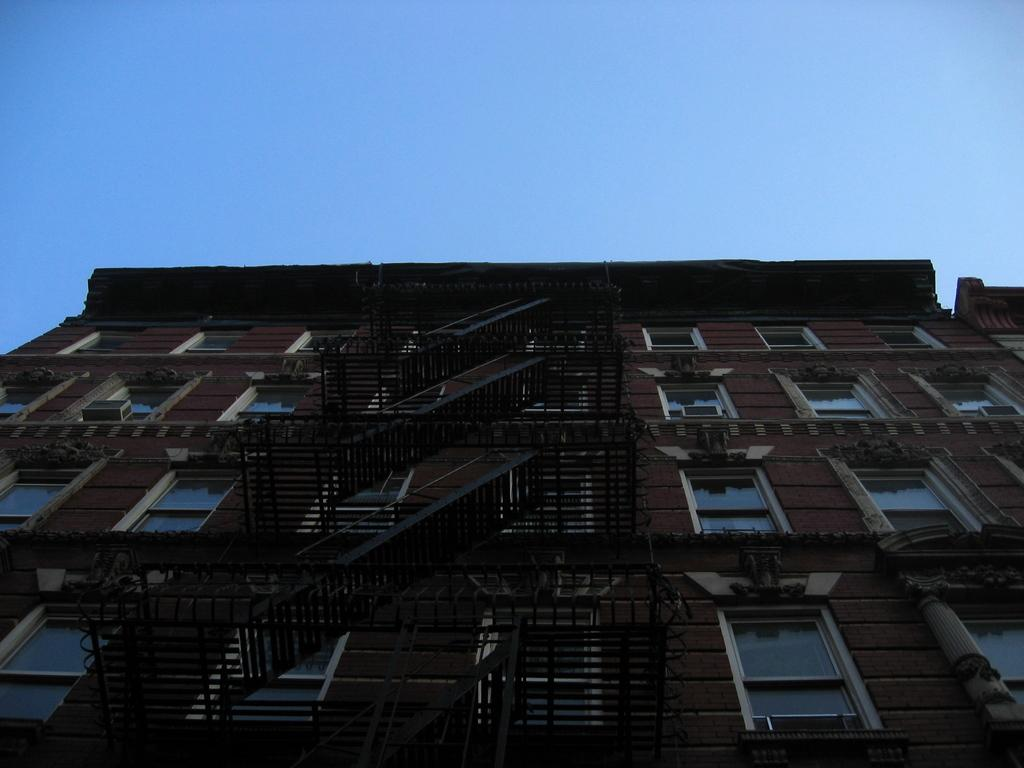What is visible at the top of the image? The sky is visible at the top of the image. What type of structure can be seen in the image? There is a building in the image. What architectural feature is present in the building? There are staircases in the image. What allows light and air to enter the building? There are windows in the image. What type of yam is being used to construct the bridge in the image? There is no bridge or yam present in the image. How many arms are visible on the people in the image? There are no people visible in the image, so it is not possible to determine the number of arms. 